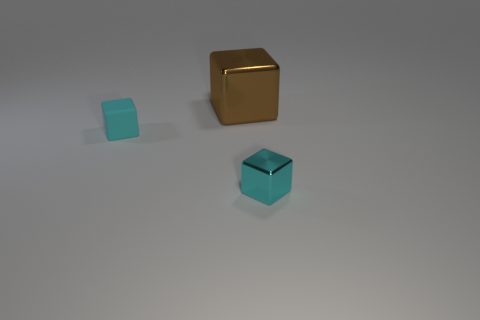What shape is the tiny metallic object that is the same color as the small rubber thing?
Ensure brevity in your answer.  Cube. How many big things are either metallic cubes or gray cylinders?
Your response must be concise. 1. There is a shiny thing in front of the rubber block; is its shape the same as the large object?
Provide a short and direct response. Yes. Are there fewer matte things than blue rubber cylinders?
Provide a short and direct response. No. Is there anything else of the same color as the large metallic object?
Ensure brevity in your answer.  No. What shape is the cyan matte thing left of the large metallic thing?
Provide a short and direct response. Cube. Does the matte thing have the same color as the object that is behind the small matte cube?
Your answer should be compact. No. Are there an equal number of tiny cyan rubber blocks in front of the cyan shiny block and large blocks in front of the small rubber object?
Provide a succinct answer. Yes. How many other things are the same size as the cyan matte block?
Give a very brief answer. 1. What is the size of the cyan metallic block?
Keep it short and to the point. Small. 